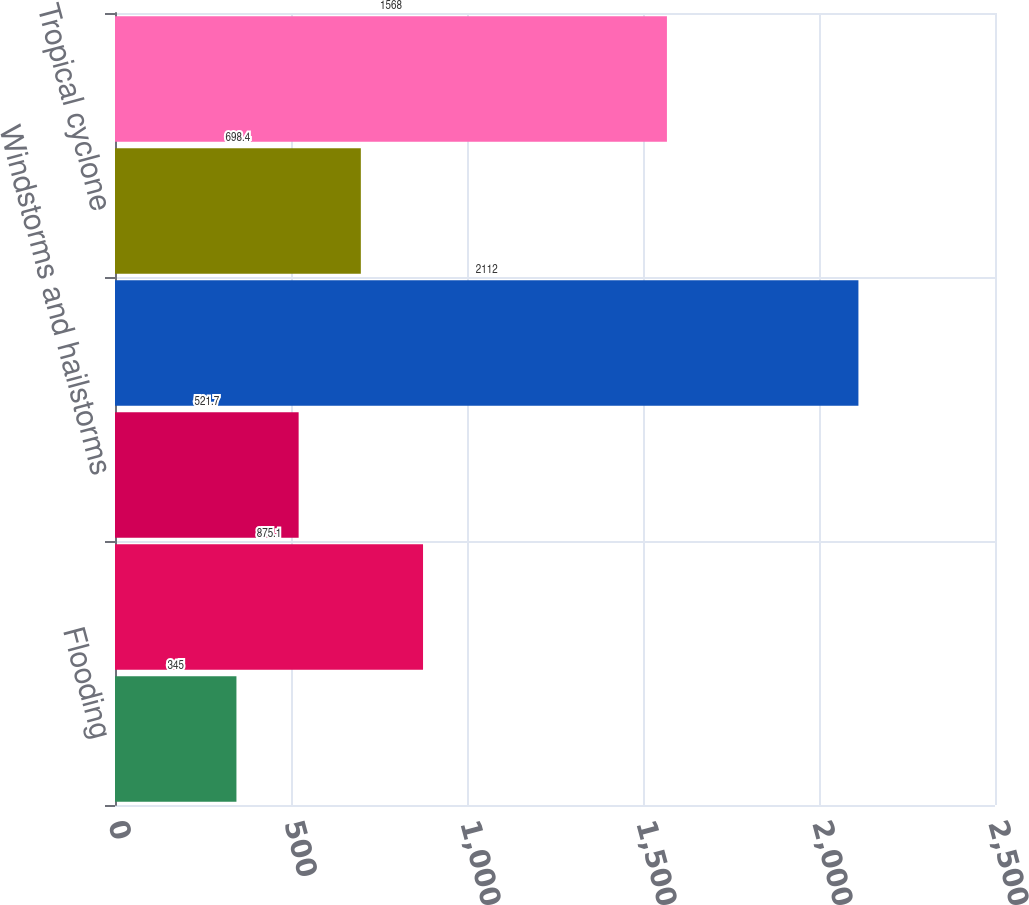<chart> <loc_0><loc_0><loc_500><loc_500><bar_chart><fcel>Flooding<fcel>Total catastrophe-related<fcel>Windstorms and hailstorms<fcel>Tropical cyclone (b)<fcel>Tropical cyclone<fcel>Earthquakes (c)<nl><fcel>345<fcel>875.1<fcel>521.7<fcel>2112<fcel>698.4<fcel>1568<nl></chart> 